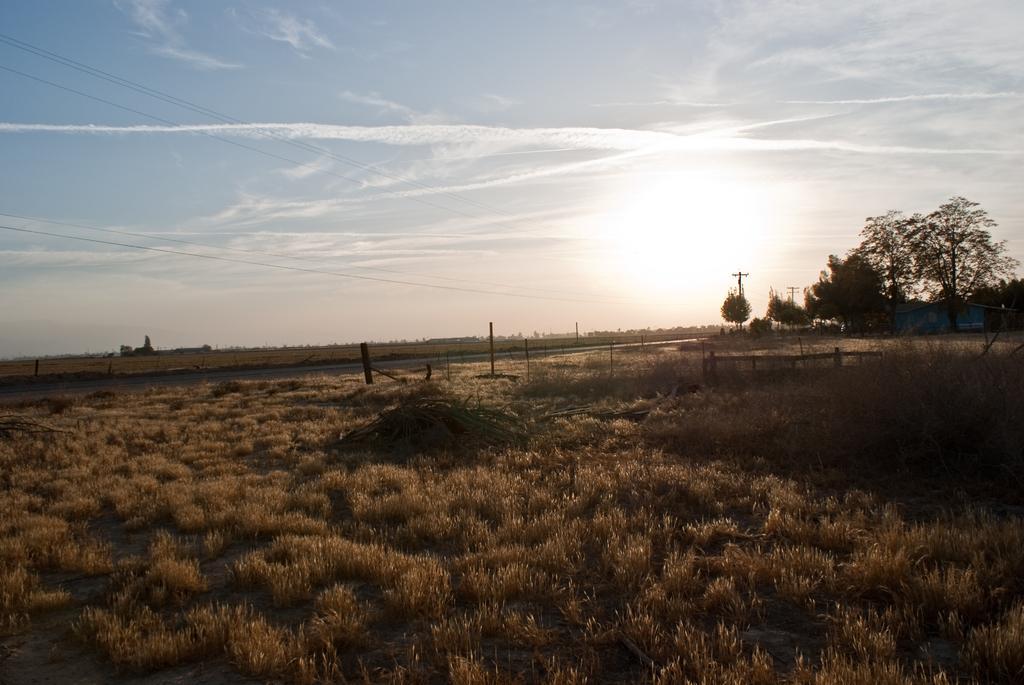Can you describe this image briefly? This is an outside view. At the bottom of the image I can see the grass. In the background there is a road and some trees and also I can see a house. On the top of the image I can see the sky. 